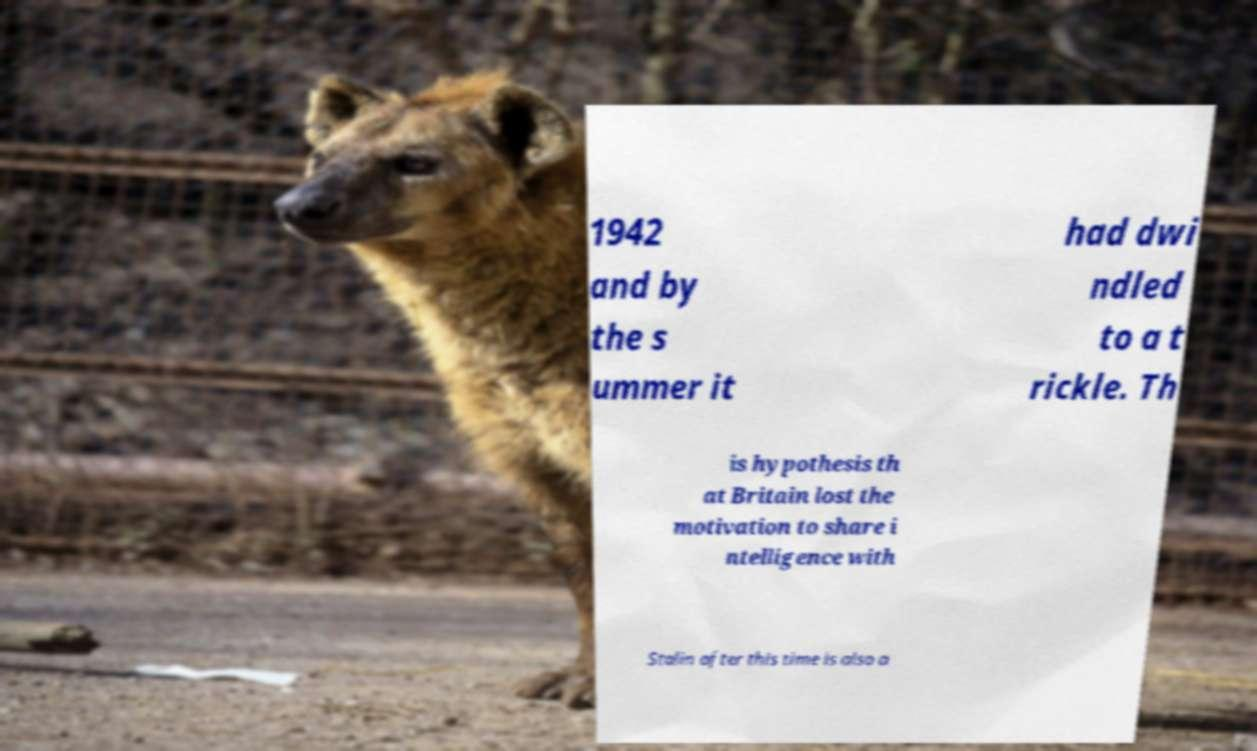Can you accurately transcribe the text from the provided image for me? 1942 and by the s ummer it had dwi ndled to a t rickle. Th is hypothesis th at Britain lost the motivation to share i ntelligence with Stalin after this time is also a 